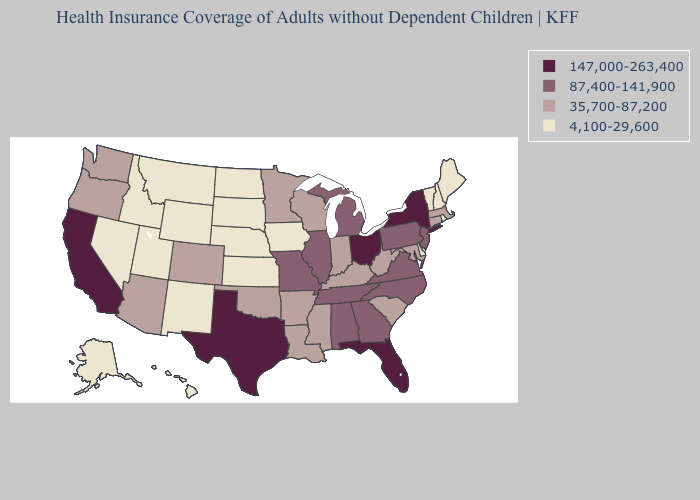What is the value of Alabama?
Quick response, please. 87,400-141,900. What is the highest value in states that border Idaho?
Answer briefly. 35,700-87,200. What is the value of Mississippi?
Give a very brief answer. 35,700-87,200. What is the value of Mississippi?
Keep it brief. 35,700-87,200. Name the states that have a value in the range 147,000-263,400?
Short answer required. California, Florida, New York, Ohio, Texas. Does California have the same value as Texas?
Concise answer only. Yes. Name the states that have a value in the range 87,400-141,900?
Keep it brief. Alabama, Georgia, Illinois, Michigan, Missouri, New Jersey, North Carolina, Pennsylvania, Tennessee, Virginia. What is the value of Alabama?
Short answer required. 87,400-141,900. What is the lowest value in the MidWest?
Quick response, please. 4,100-29,600. Does the first symbol in the legend represent the smallest category?
Keep it brief. No. What is the value of Vermont?
Keep it brief. 4,100-29,600. Name the states that have a value in the range 35,700-87,200?
Write a very short answer. Arizona, Arkansas, Colorado, Connecticut, Indiana, Kentucky, Louisiana, Maryland, Massachusetts, Minnesota, Mississippi, Oklahoma, Oregon, South Carolina, Washington, West Virginia, Wisconsin. Name the states that have a value in the range 4,100-29,600?
Quick response, please. Alaska, Delaware, Hawaii, Idaho, Iowa, Kansas, Maine, Montana, Nebraska, Nevada, New Hampshire, New Mexico, North Dakota, Rhode Island, South Dakota, Utah, Vermont, Wyoming. What is the lowest value in the Northeast?
Keep it brief. 4,100-29,600. 